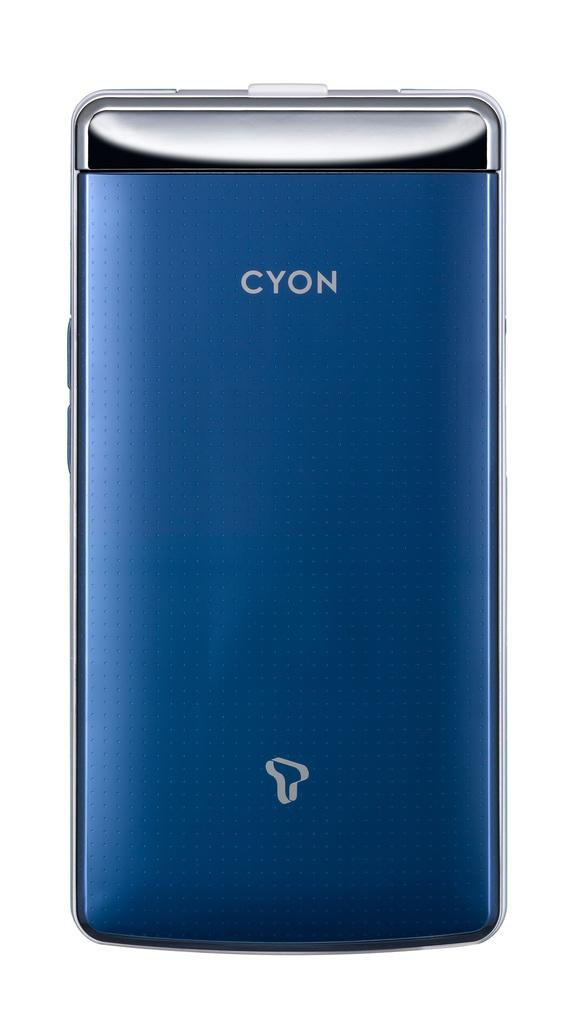<image>
Render a clear and concise summary of the photo. A blue phone that reads CYON against a white background. 